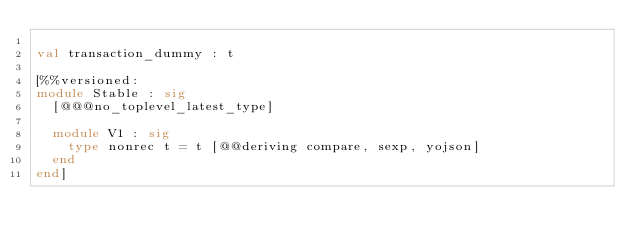<code> <loc_0><loc_0><loc_500><loc_500><_OCaml_>
val transaction_dummy : t

[%%versioned:
module Stable : sig
  [@@@no_toplevel_latest_type]

  module V1 : sig
    type nonrec t = t [@@deriving compare, sexp, yojson]
  end
end]
</code> 